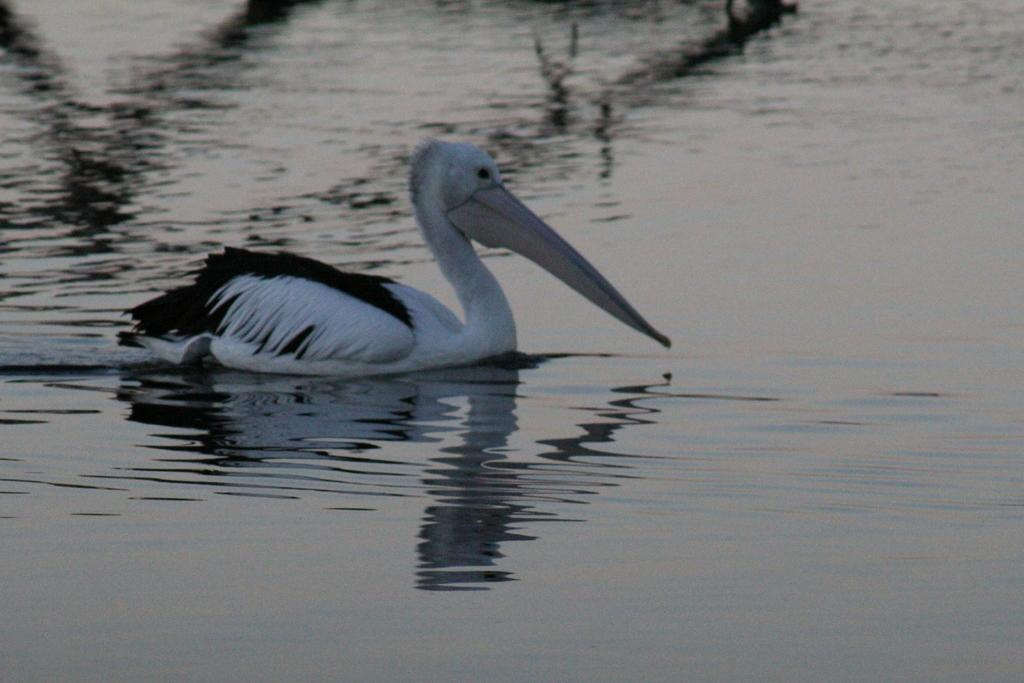What type of animal is in the image? There is a bird in the image. What colors can be seen on the bird? The bird has a white and black color combination. What is the bird doing in the image? The bird is swimming in the water. What type of creature is using the brake in the image? There is no brake present in the image, and therefore no creature is using it. 